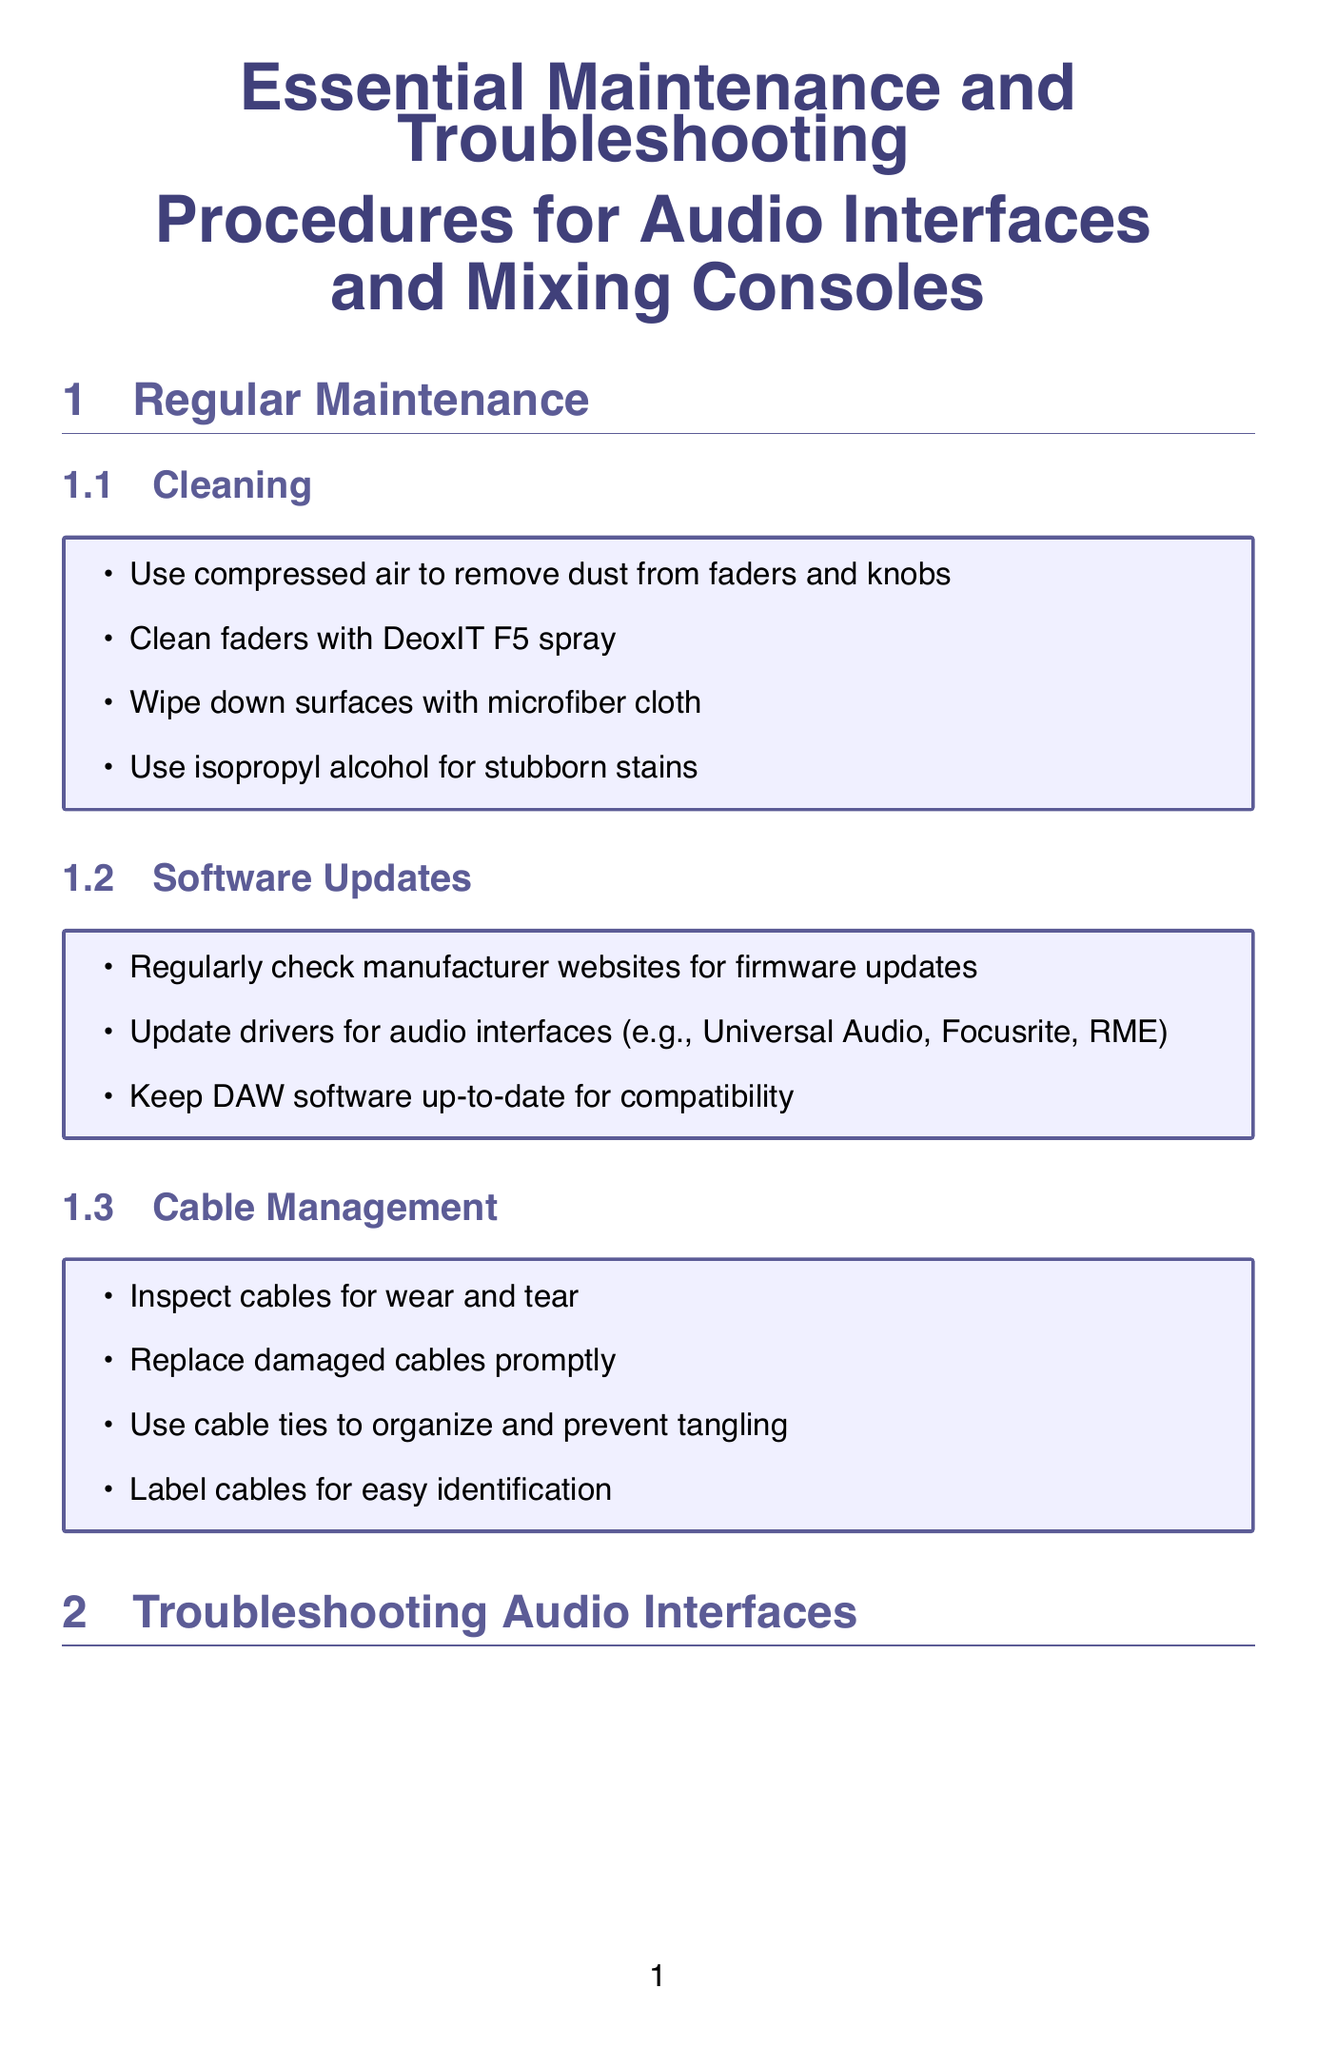what should you use to remove dust from faders? The document states that you should use compressed air to remove dust from faders and knobs.
Answer: compressed air how frequently should you perform visual inspections? The document indicates that you should schedule monthly visual inspections.
Answer: monthly what should you adjust to fix latency issues? The document mentions adjusting buffer size in DAW settings as a solution for latency issues.
Answer: buffer size which tool is recommended for cleaning electrical contacts? The document lists Caig ProGold G5 spray as a tool recommended for cleaning electrical contacts.
Answer: Caig ProGold G5 spray what is a preventive measure for controlling humidity levels? The document suggests using dehumidifiers in damp environments as a preventive measure for controlling humidity levels.
Answer: dehumidifiers how often should deep cleaning be performed? According to the document, deep cleaning should be performed quarterly.
Answer: quarterly which driver type should Windows users utilize? The document advises using ASIO drivers on Windows systems to address latency issues.
Answer: ASIO drivers what voltage settings should you verify concerning power problems? The document states that you should verify proper voltage settings in case of power problems.
Answer: proper voltage settings who should perform annual professional servicing for complex equipment? The document suggests that annual professional servicing should be done for complex equipment.
Answer: professional servicing 